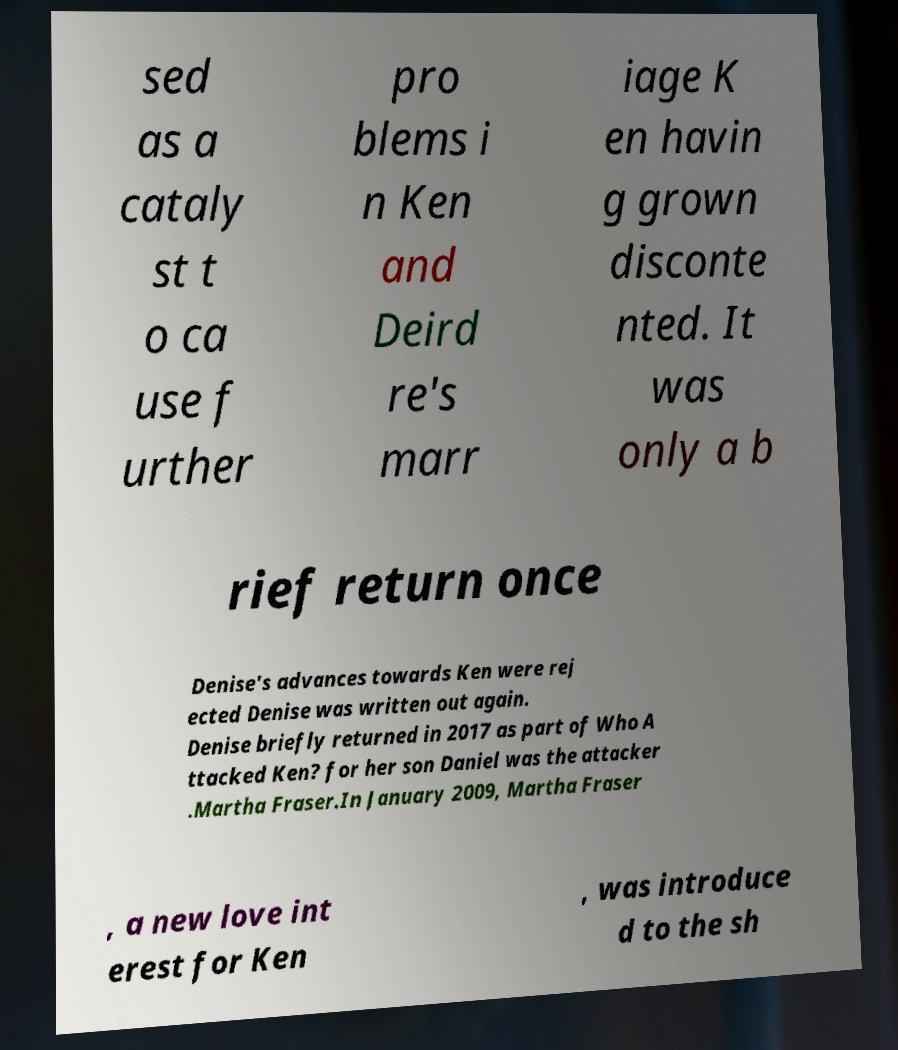Could you extract and type out the text from this image? sed as a cataly st t o ca use f urther pro blems i n Ken and Deird re's marr iage K en havin g grown disconte nted. It was only a b rief return once Denise's advances towards Ken were rej ected Denise was written out again. Denise briefly returned in 2017 as part of Who A ttacked Ken? for her son Daniel was the attacker .Martha Fraser.In January 2009, Martha Fraser , a new love int erest for Ken , was introduce d to the sh 